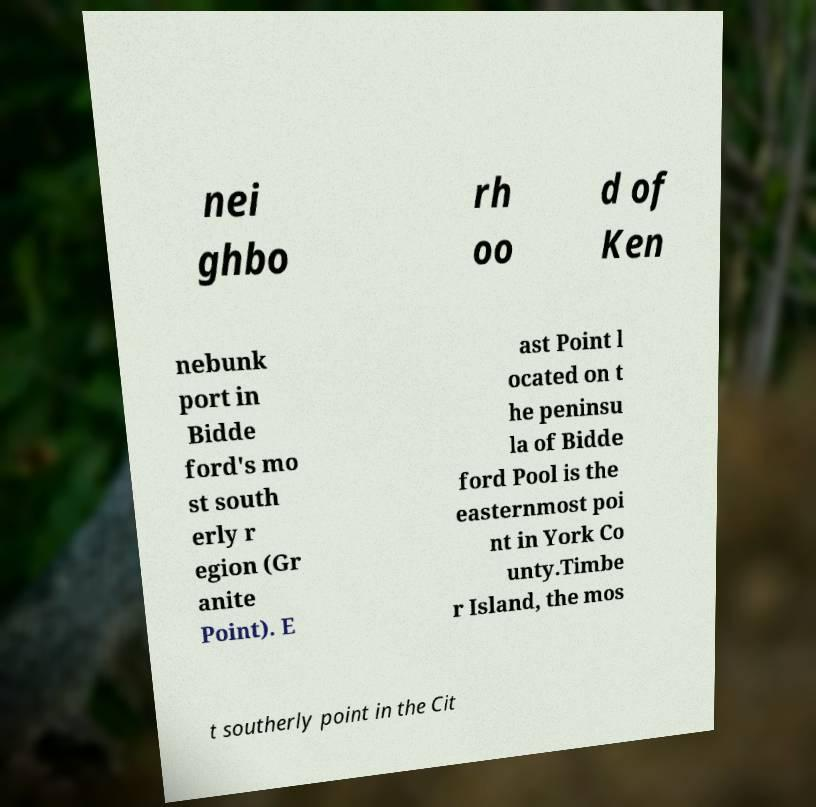Please identify and transcribe the text found in this image. nei ghbo rh oo d of Ken nebunk port in Bidde ford's mo st south erly r egion (Gr anite Point). E ast Point l ocated on t he peninsu la of Bidde ford Pool is the easternmost poi nt in York Co unty.Timbe r Island, the mos t southerly point in the Cit 